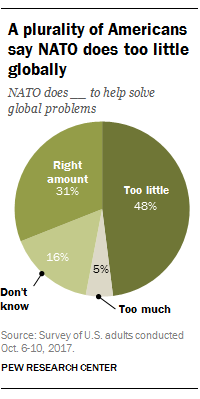List a handful of essential elements in this visual. Too much segmentation can result in a low percentage value. Out of the segment values, two exceeded 30%. 